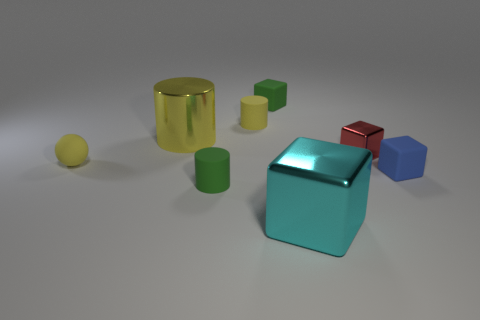Are there any yellow objects behind the green matte cube?
Ensure brevity in your answer.  No. What number of shiny objects are there?
Your response must be concise. 3. What number of large shiny cubes are left of the cube that is in front of the green matte cylinder?
Make the answer very short. 0. Do the big cylinder and the tiny matte block on the right side of the small metallic block have the same color?
Ensure brevity in your answer.  No. How many big cyan objects are the same shape as the tiny red metal thing?
Your answer should be compact. 1. There is a small green object in front of the tiny green matte cube; what is its material?
Keep it short and to the point. Rubber. Does the green rubber thing that is in front of the small blue object have the same shape as the yellow metallic object?
Provide a succinct answer. Yes. Are there any spheres that have the same size as the yellow rubber cylinder?
Make the answer very short. Yes. Is the shape of the small blue matte thing the same as the shiny thing that is on the right side of the cyan cube?
Provide a succinct answer. Yes. What shape is the big shiny object that is the same color as the tiny sphere?
Your answer should be very brief. Cylinder. 